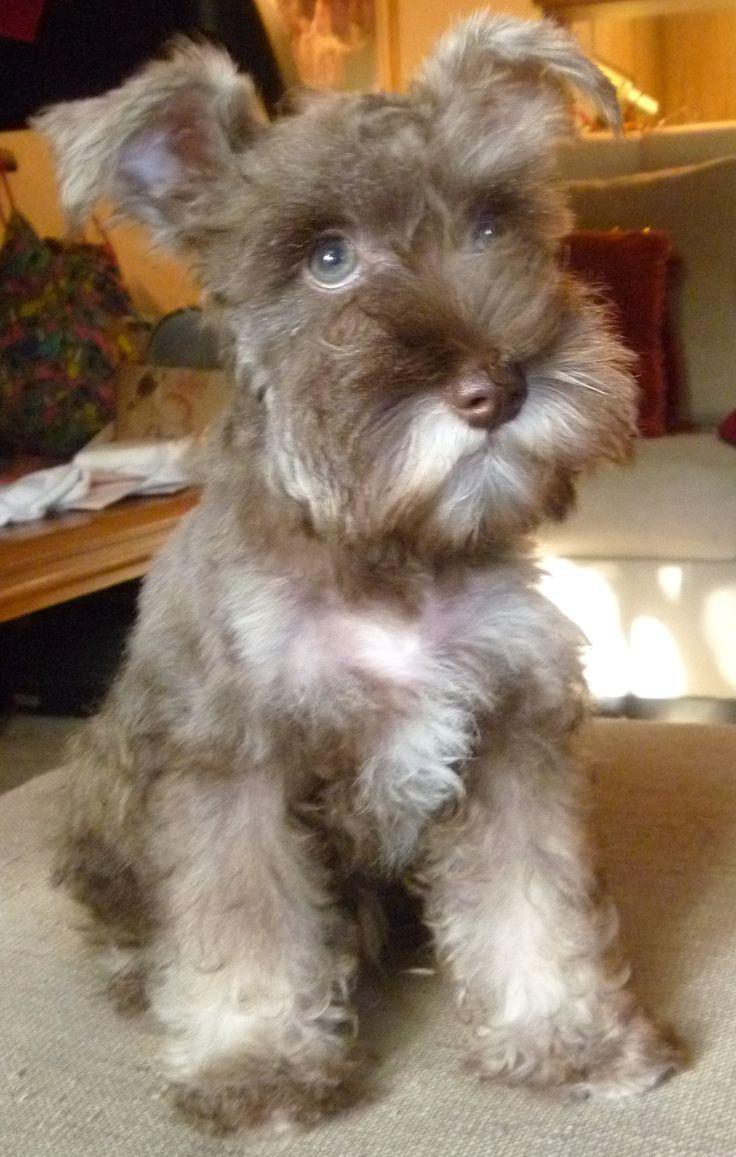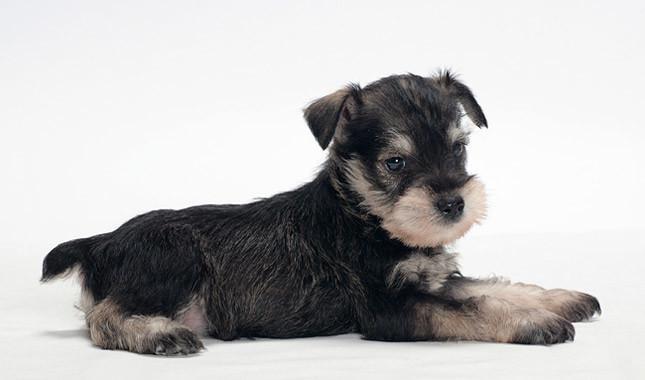The first image is the image on the left, the second image is the image on the right. Evaluate the accuracy of this statement regarding the images: "An image shows an animal with all-white fur.". Is it true? Answer yes or no. No. 